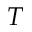<formula> <loc_0><loc_0><loc_500><loc_500>T</formula> 